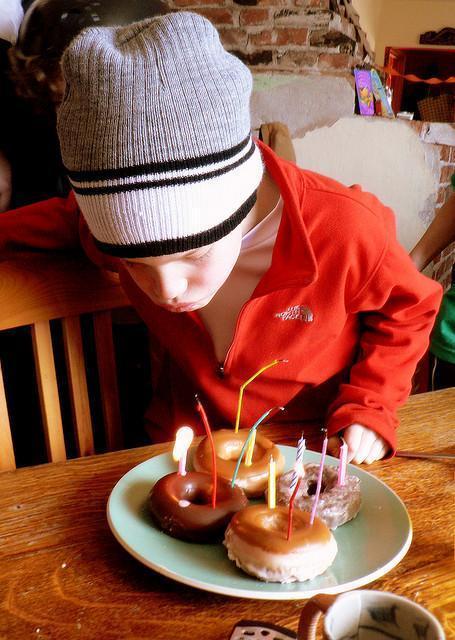How many doughnuts are in the photo?
Give a very brief answer. 4. How many donuts are in the picture?
Give a very brief answer. 4. How many chairs are in the picture?
Give a very brief answer. 1. How many people are in the picture?
Give a very brief answer. 2. How many zebras are here?
Give a very brief answer. 0. 